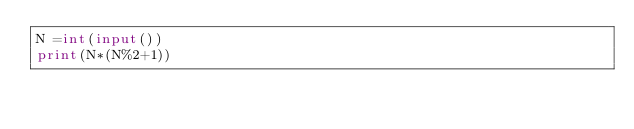<code> <loc_0><loc_0><loc_500><loc_500><_Python_>N =int(input())
print(N*(N%2+1))</code> 